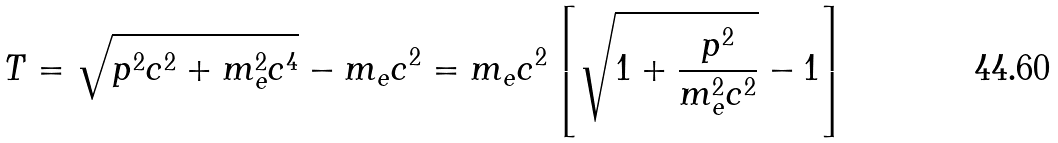Convert formula to latex. <formula><loc_0><loc_0><loc_500><loc_500>T = { \sqrt { p ^ { 2 } c ^ { 2 } + m _ { e } ^ { 2 } c ^ { 4 } } } - m _ { e } c ^ { 2 } = m _ { e } c ^ { 2 } \left [ { \sqrt { 1 + { \frac { p ^ { 2 } } { m _ { e } ^ { 2 } c ^ { 2 } } } } } - 1 \right ]</formula> 